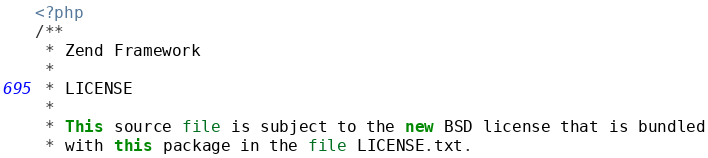Convert code to text. <code><loc_0><loc_0><loc_500><loc_500><_PHP_><?php
/**
 * Zend Framework
 *
 * LICENSE
 *
 * This source file is subject to the new BSD license that is bundled
 * with this package in the file LICENSE.txt.</code> 